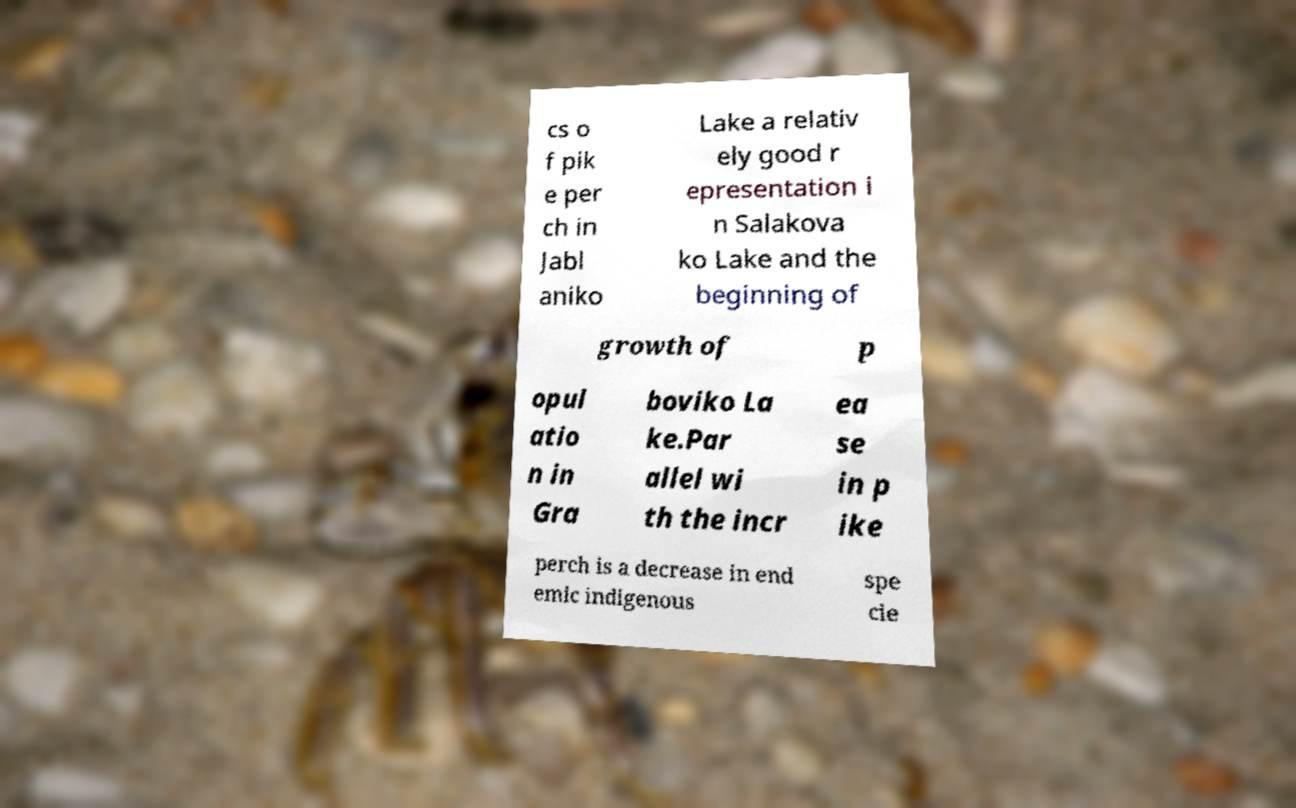There's text embedded in this image that I need extracted. Can you transcribe it verbatim? cs o f pik e per ch in Jabl aniko Lake a relativ ely good r epresentation i n Salakova ko Lake and the beginning of growth of p opul atio n in Gra boviko La ke.Par allel wi th the incr ea se in p ike perch is a decrease in end emic indigenous spe cie 